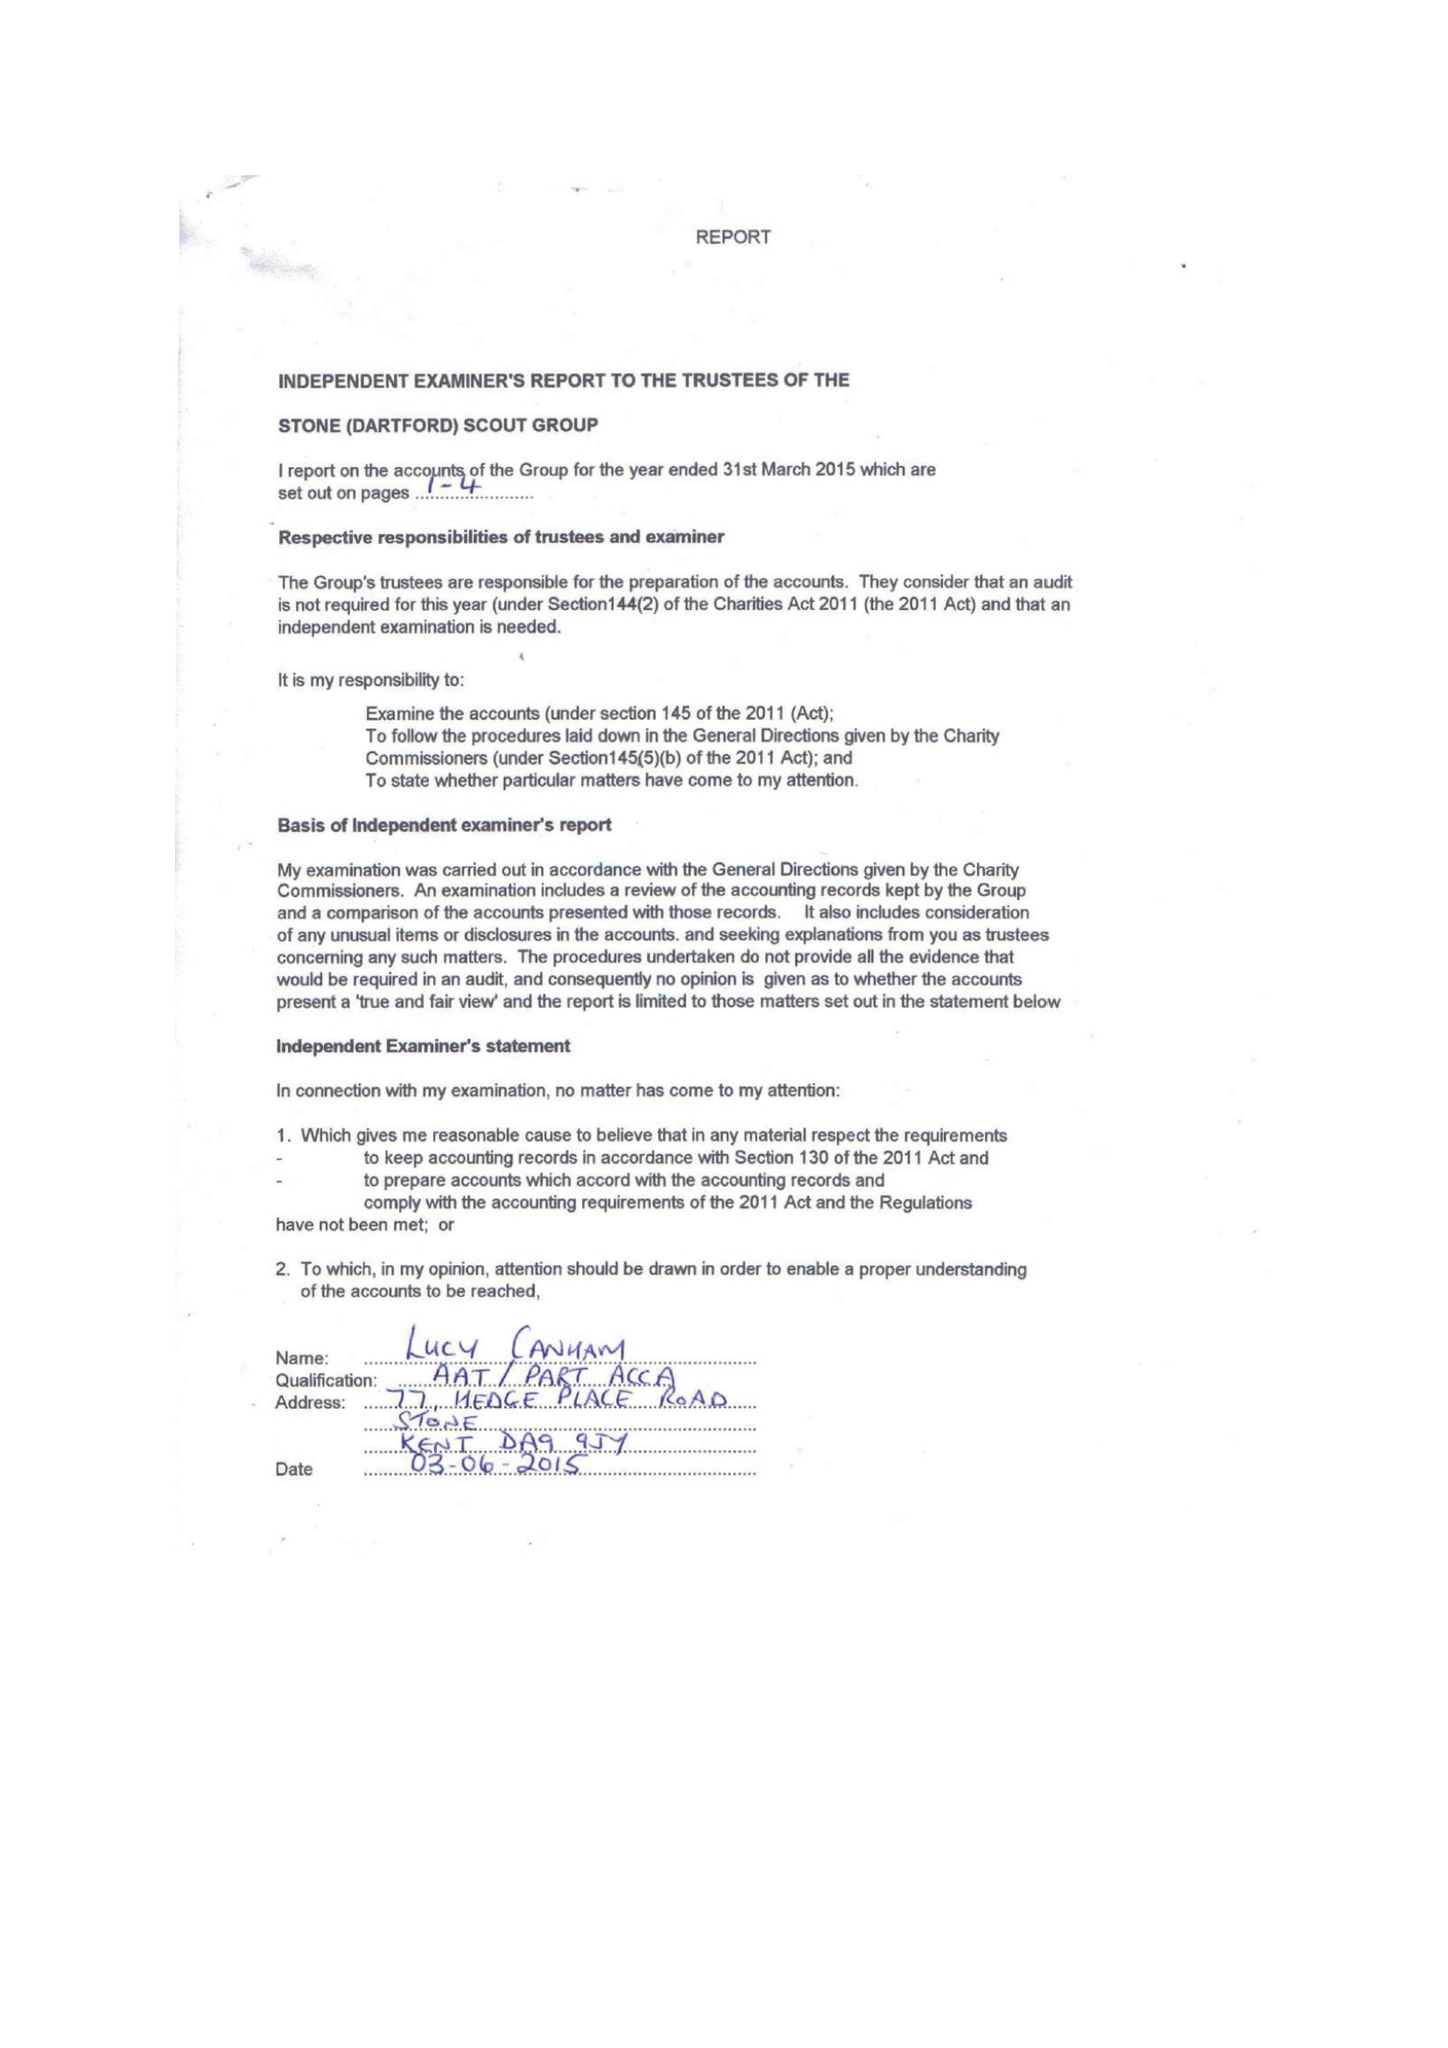What is the value for the income_annually_in_british_pounds?
Answer the question using a single word or phrase. 32654.00 